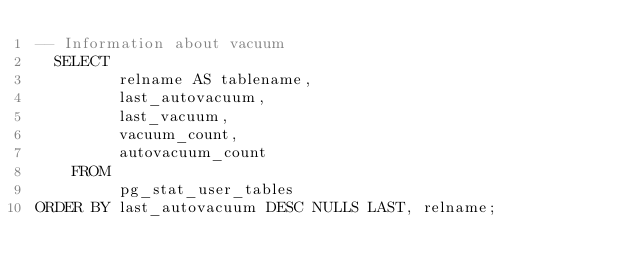<code> <loc_0><loc_0><loc_500><loc_500><_SQL_>-- Information about vacuum
  SELECT
         relname AS tablename,
         last_autovacuum,
         last_vacuum,
         vacuum_count,
         autovacuum_count
    FROM
         pg_stat_user_tables
ORDER BY last_autovacuum DESC NULLS LAST, relname;
</code> 